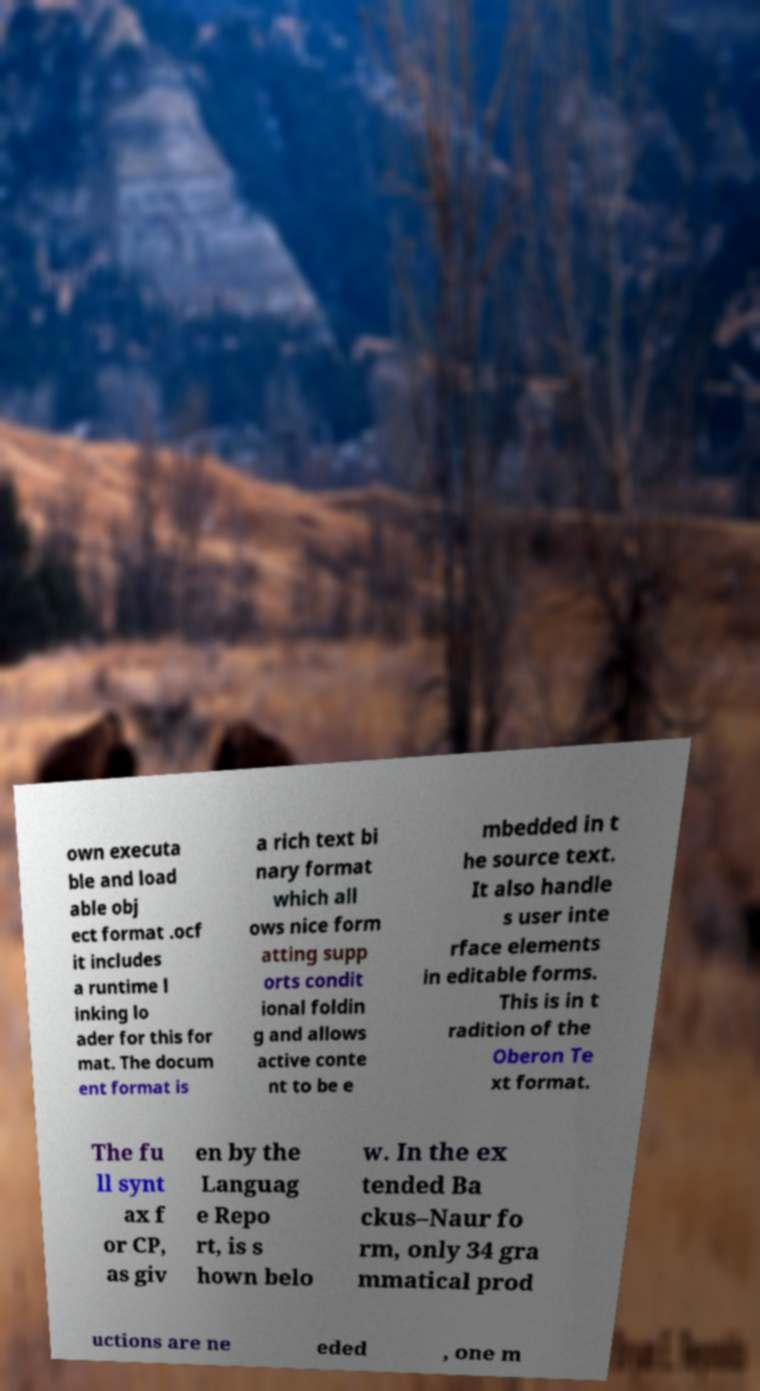What messages or text are displayed in this image? I need them in a readable, typed format. own executa ble and load able obj ect format .ocf it includes a runtime l inking lo ader for this for mat. The docum ent format is a rich text bi nary format which all ows nice form atting supp orts condit ional foldin g and allows active conte nt to be e mbedded in t he source text. It also handle s user inte rface elements in editable forms. This is in t radition of the Oberon Te xt format. The fu ll synt ax f or CP, as giv en by the Languag e Repo rt, is s hown belo w. In the ex tended Ba ckus–Naur fo rm, only 34 gra mmatical prod uctions are ne eded , one m 